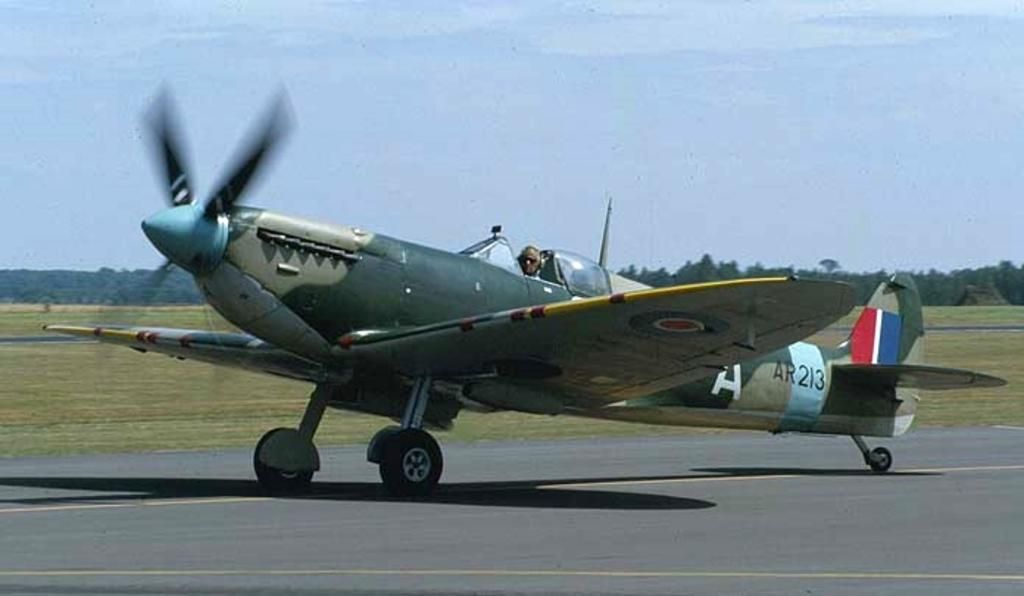<image>
Share a concise interpretation of the image provided. An airplane has AR213 painted on the side of it. 